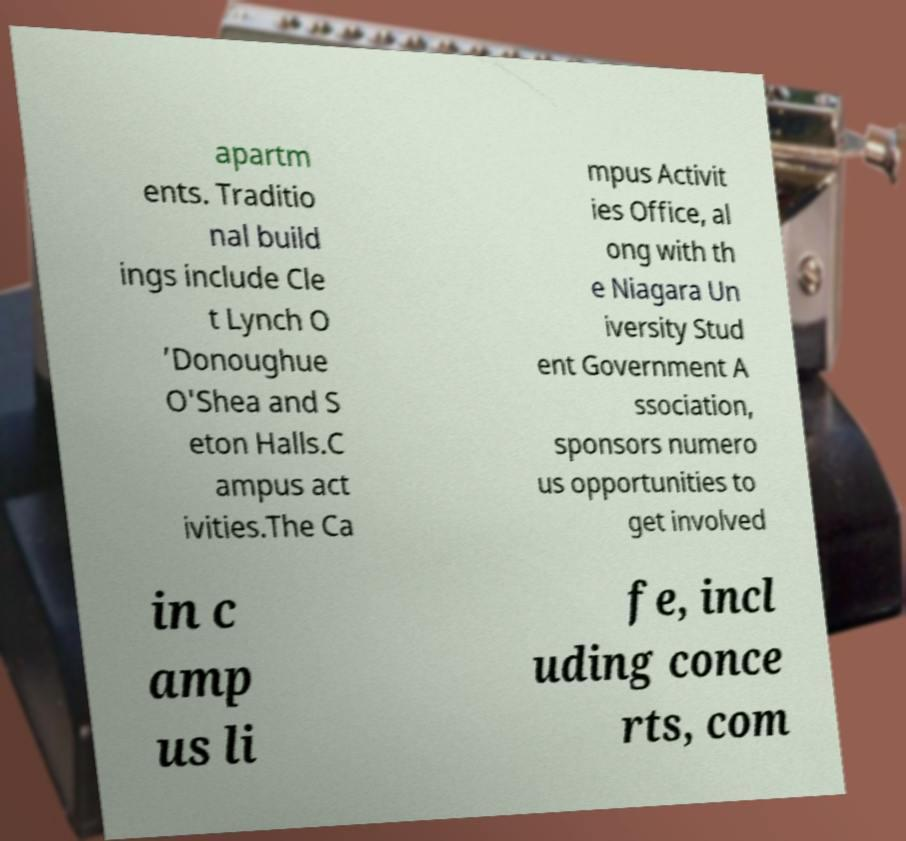Could you assist in decoding the text presented in this image and type it out clearly? apartm ents. Traditio nal build ings include Cle t Lynch O ’Donoughue O'Shea and S eton Halls.C ampus act ivities.The Ca mpus Activit ies Office, al ong with th e Niagara Un iversity Stud ent Government A ssociation, sponsors numero us opportunities to get involved in c amp us li fe, incl uding conce rts, com 